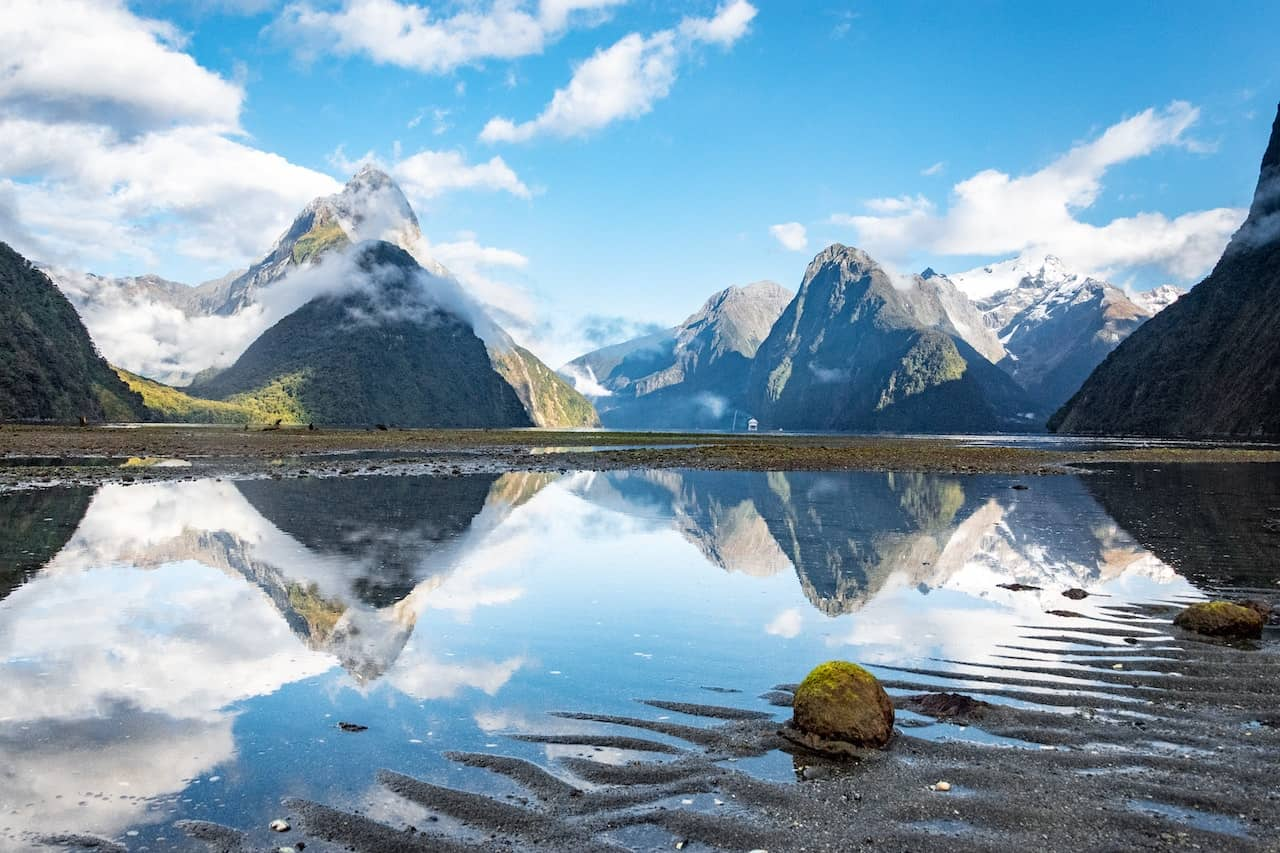How might the serene environment of Milford Sound impact its ecosystem? The serene environment of Milford Sound significantly impacts its ecosystem by creating a stable and balanced habitat for flora and fauna. The abundant water provides a constant moisture source, essential for the lush vegetation seen around the area. This dense vegetation, in turn, supports a variety of wildlife, including birds and aquatic species. The isolation and tranquility of Milford Sound also help maintain low levels of pollution and human disturbance, which are crucial for the preservation of natural habitats and biodiversity. 